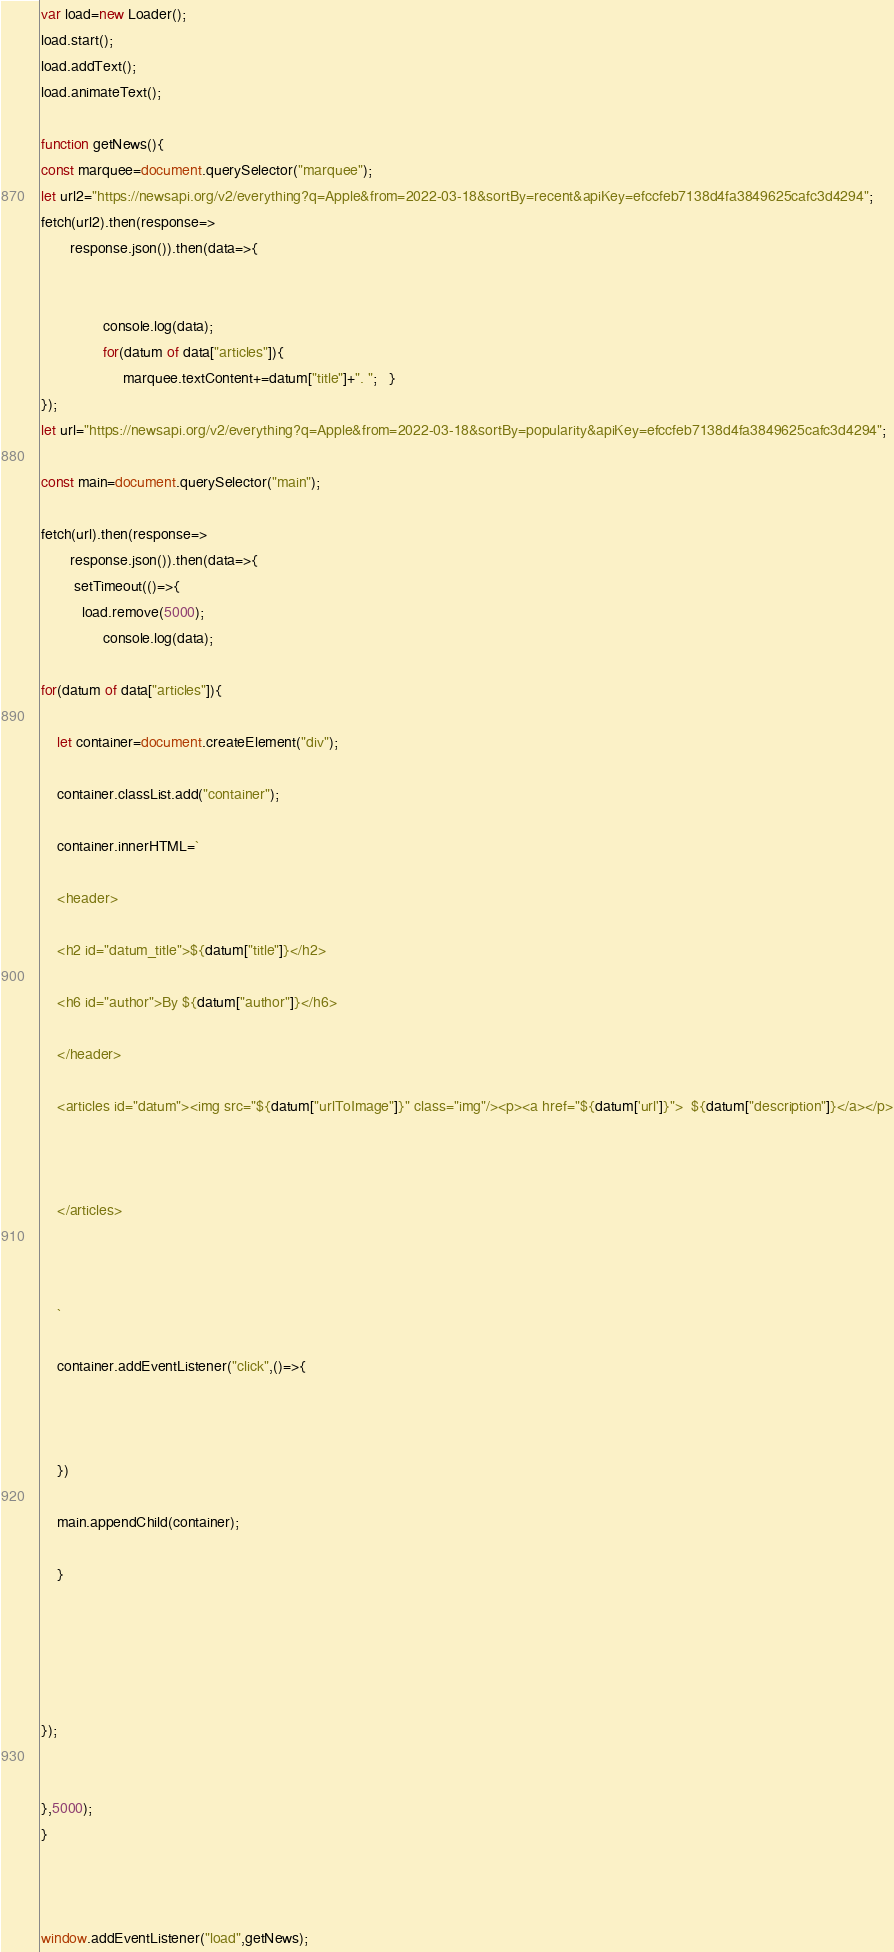Convert code to text. <code><loc_0><loc_0><loc_500><loc_500><_JavaScript_>
var load=new Loader();
load.start();
load.addText();
load.animateText();

function getNews(){
const marquee=document.querySelector("marquee");
let url2="https://newsapi.org/v2/everything?q=Apple&from=2022-03-18&sortBy=recent&apiKey=efccfeb7138d4fa3849625cafc3d4294";
fetch(url2).then(response=>
       response.json()).then(data=>{
      
  
               console.log(data);
               for(datum of data["articles"]){
                    marquee.textContent+=datum["title"]+". ";   }
});
let url="https://newsapi.org/v2/everything?q=Apple&from=2022-03-18&sortBy=popularity&apiKey=efccfeb7138d4fa3849625cafc3d4294";

const main=document.querySelector("main");

fetch(url).then(response=>
       response.json()).then(data=>{
       	setTimeout(()=>{
          load.remove(5000);
               console.log(data);

for(datum of data["articles"]){

	let container=document.createElement("div");

	container.classList.add("container");

	container.innerHTML=`

	<header>

	<h2 id="datum_title">${datum["title"]}</h2>

	<h6 id="author">By ${datum["author"]}</h6>

	</header>

	<articles id="datum"><img src="${datum["urlToImage"]}" class="img"/><p><a href="${datum['url']}">	${datum["description"]}</a></p>



	</articles>

	

	`

	container.addEventListener("click",()=>{

	       

	})

	main.appendChild(container);

	}





});


},5000);
}



window.addEventListener("load",getNews);


</code> 